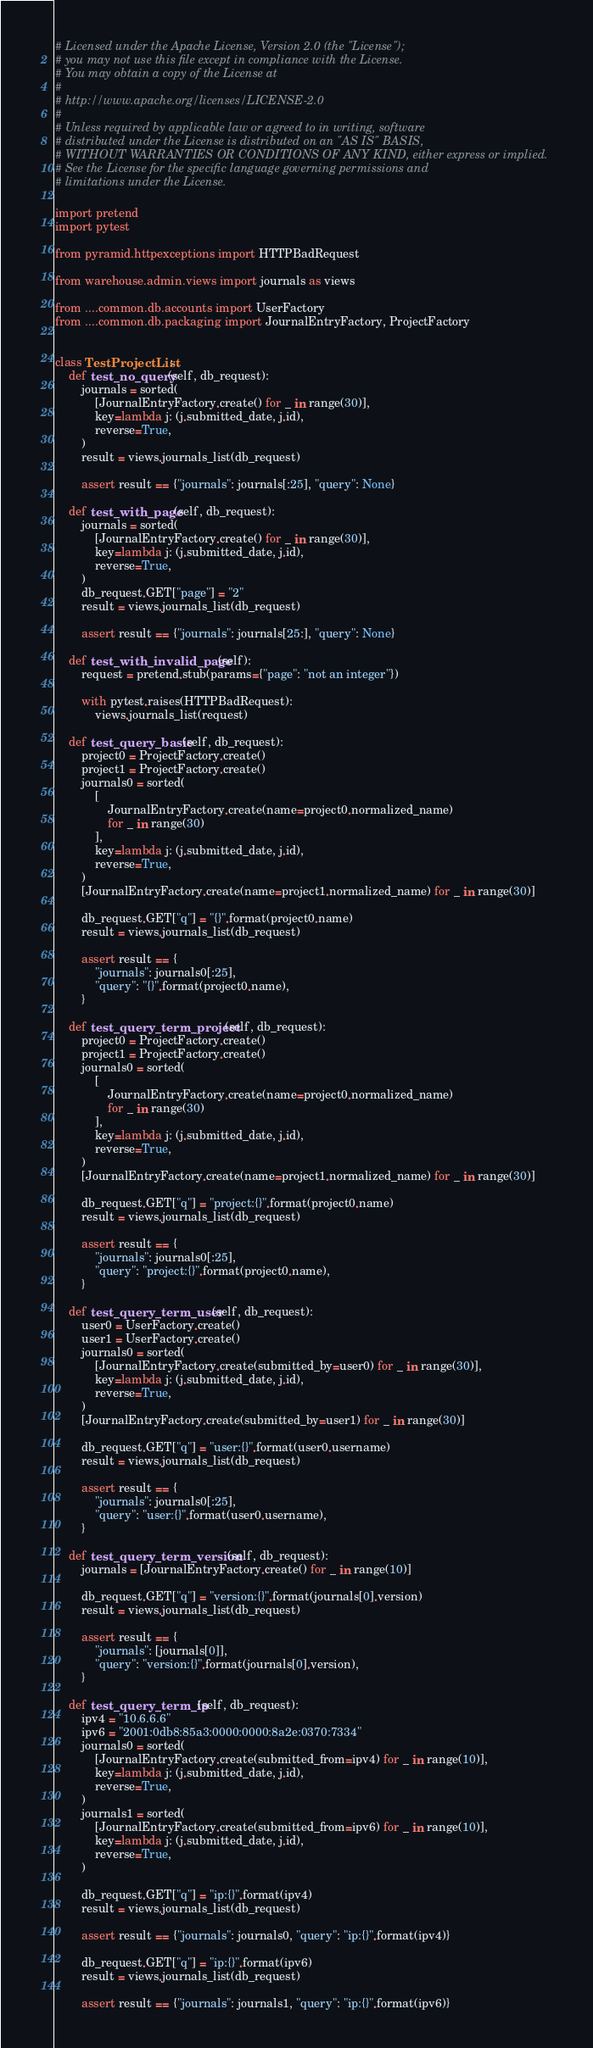Convert code to text. <code><loc_0><loc_0><loc_500><loc_500><_Python_># Licensed under the Apache License, Version 2.0 (the "License");
# you may not use this file except in compliance with the License.
# You may obtain a copy of the License at
#
# http://www.apache.org/licenses/LICENSE-2.0
#
# Unless required by applicable law or agreed to in writing, software
# distributed under the License is distributed on an "AS IS" BASIS,
# WITHOUT WARRANTIES OR CONDITIONS OF ANY KIND, either express or implied.
# See the License for the specific language governing permissions and
# limitations under the License.

import pretend
import pytest

from pyramid.httpexceptions import HTTPBadRequest

from warehouse.admin.views import journals as views

from ....common.db.accounts import UserFactory
from ....common.db.packaging import JournalEntryFactory, ProjectFactory


class TestProjectList:
    def test_no_query(self, db_request):
        journals = sorted(
            [JournalEntryFactory.create() for _ in range(30)],
            key=lambda j: (j.submitted_date, j.id),
            reverse=True,
        )
        result = views.journals_list(db_request)

        assert result == {"journals": journals[:25], "query": None}

    def test_with_page(self, db_request):
        journals = sorted(
            [JournalEntryFactory.create() for _ in range(30)],
            key=lambda j: (j.submitted_date, j.id),
            reverse=True,
        )
        db_request.GET["page"] = "2"
        result = views.journals_list(db_request)

        assert result == {"journals": journals[25:], "query": None}

    def test_with_invalid_page(self):
        request = pretend.stub(params={"page": "not an integer"})

        with pytest.raises(HTTPBadRequest):
            views.journals_list(request)

    def test_query_basic(self, db_request):
        project0 = ProjectFactory.create()
        project1 = ProjectFactory.create()
        journals0 = sorted(
            [
                JournalEntryFactory.create(name=project0.normalized_name)
                for _ in range(30)
            ],
            key=lambda j: (j.submitted_date, j.id),
            reverse=True,
        )
        [JournalEntryFactory.create(name=project1.normalized_name) for _ in range(30)]

        db_request.GET["q"] = "{}".format(project0.name)
        result = views.journals_list(db_request)

        assert result == {
            "journals": journals0[:25],
            "query": "{}".format(project0.name),
        }

    def test_query_term_project(self, db_request):
        project0 = ProjectFactory.create()
        project1 = ProjectFactory.create()
        journals0 = sorted(
            [
                JournalEntryFactory.create(name=project0.normalized_name)
                for _ in range(30)
            ],
            key=lambda j: (j.submitted_date, j.id),
            reverse=True,
        )
        [JournalEntryFactory.create(name=project1.normalized_name) for _ in range(30)]

        db_request.GET["q"] = "project:{}".format(project0.name)
        result = views.journals_list(db_request)

        assert result == {
            "journals": journals0[:25],
            "query": "project:{}".format(project0.name),
        }

    def test_query_term_user(self, db_request):
        user0 = UserFactory.create()
        user1 = UserFactory.create()
        journals0 = sorted(
            [JournalEntryFactory.create(submitted_by=user0) for _ in range(30)],
            key=lambda j: (j.submitted_date, j.id),
            reverse=True,
        )
        [JournalEntryFactory.create(submitted_by=user1) for _ in range(30)]

        db_request.GET["q"] = "user:{}".format(user0.username)
        result = views.journals_list(db_request)

        assert result == {
            "journals": journals0[:25],
            "query": "user:{}".format(user0.username),
        }

    def test_query_term_version(self, db_request):
        journals = [JournalEntryFactory.create() for _ in range(10)]

        db_request.GET["q"] = "version:{}".format(journals[0].version)
        result = views.journals_list(db_request)

        assert result == {
            "journals": [journals[0]],
            "query": "version:{}".format(journals[0].version),
        }

    def test_query_term_ip(self, db_request):
        ipv4 = "10.6.6.6"
        ipv6 = "2001:0db8:85a3:0000:0000:8a2e:0370:7334"
        journals0 = sorted(
            [JournalEntryFactory.create(submitted_from=ipv4) for _ in range(10)],
            key=lambda j: (j.submitted_date, j.id),
            reverse=True,
        )
        journals1 = sorted(
            [JournalEntryFactory.create(submitted_from=ipv6) for _ in range(10)],
            key=lambda j: (j.submitted_date, j.id),
            reverse=True,
        )

        db_request.GET["q"] = "ip:{}".format(ipv4)
        result = views.journals_list(db_request)

        assert result == {"journals": journals0, "query": "ip:{}".format(ipv4)}

        db_request.GET["q"] = "ip:{}".format(ipv6)
        result = views.journals_list(db_request)

        assert result == {"journals": journals1, "query": "ip:{}".format(ipv6)}
</code> 